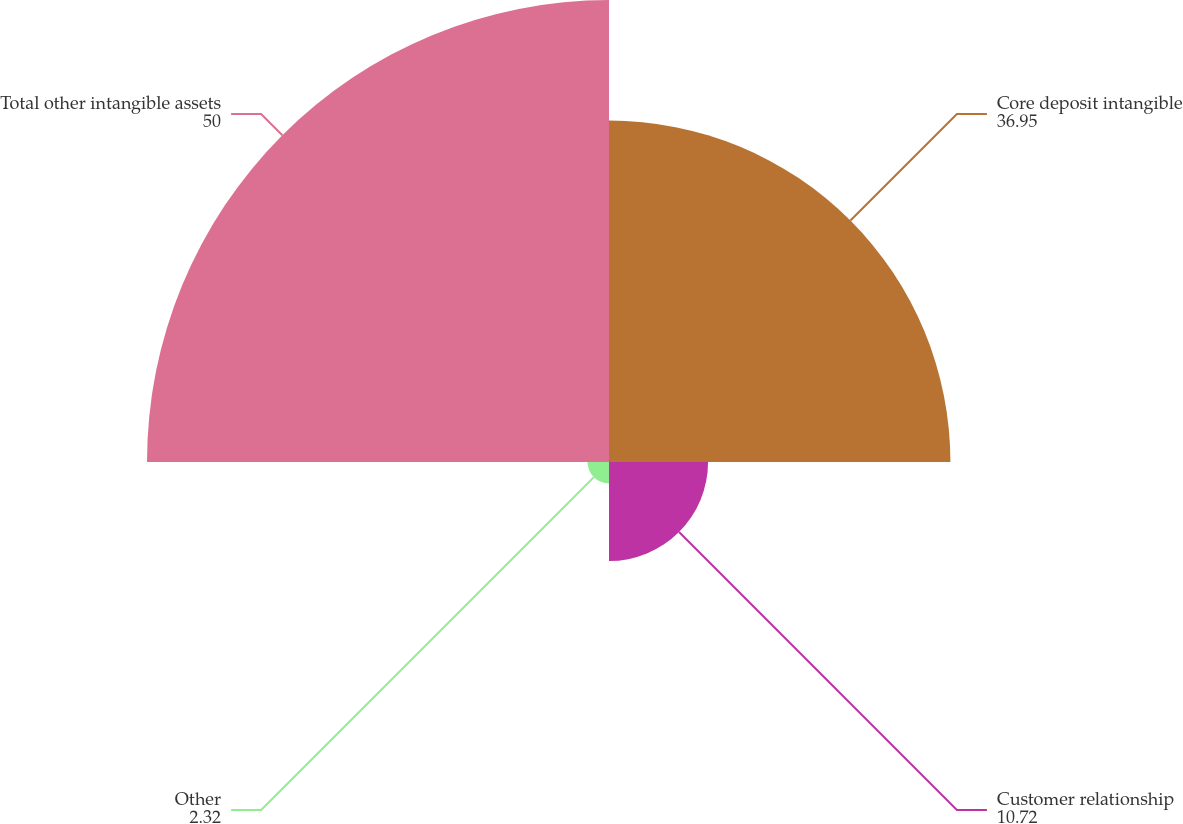<chart> <loc_0><loc_0><loc_500><loc_500><pie_chart><fcel>Core deposit intangible<fcel>Customer relationship<fcel>Other<fcel>Total other intangible assets<nl><fcel>36.95%<fcel>10.72%<fcel>2.32%<fcel>50.0%<nl></chart> 